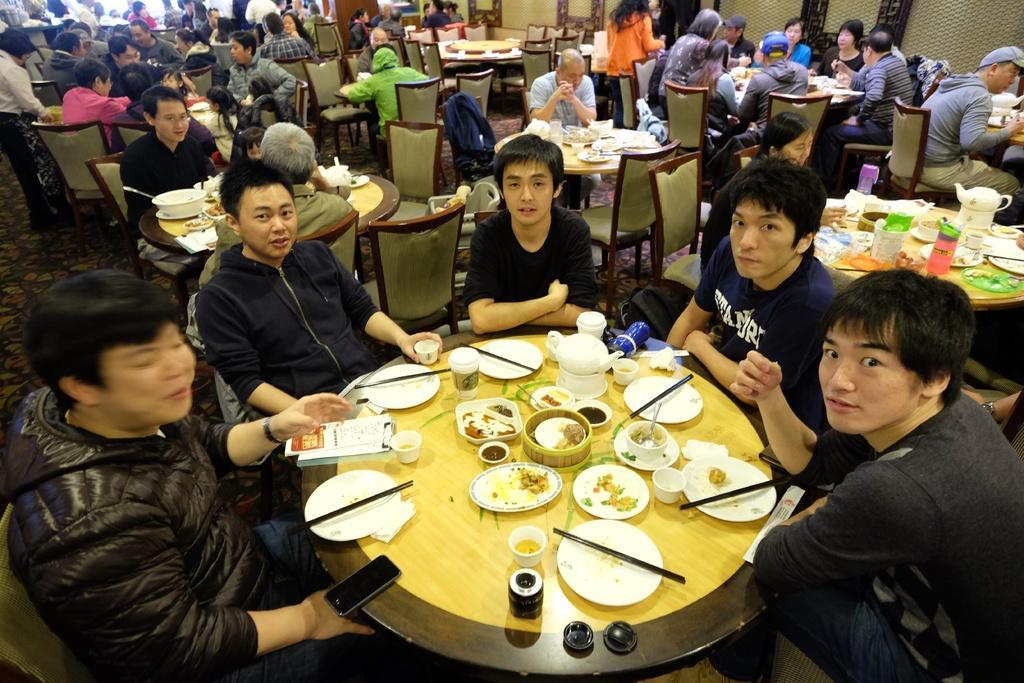How would you summarize this image in a sentence or two? Group of people sitting on the chairs,few persons are standing. We can see plates,sticks,kettles,food,bottles,bowl,cups,mobile on the tables. On the background we can see wall. This is floor. 